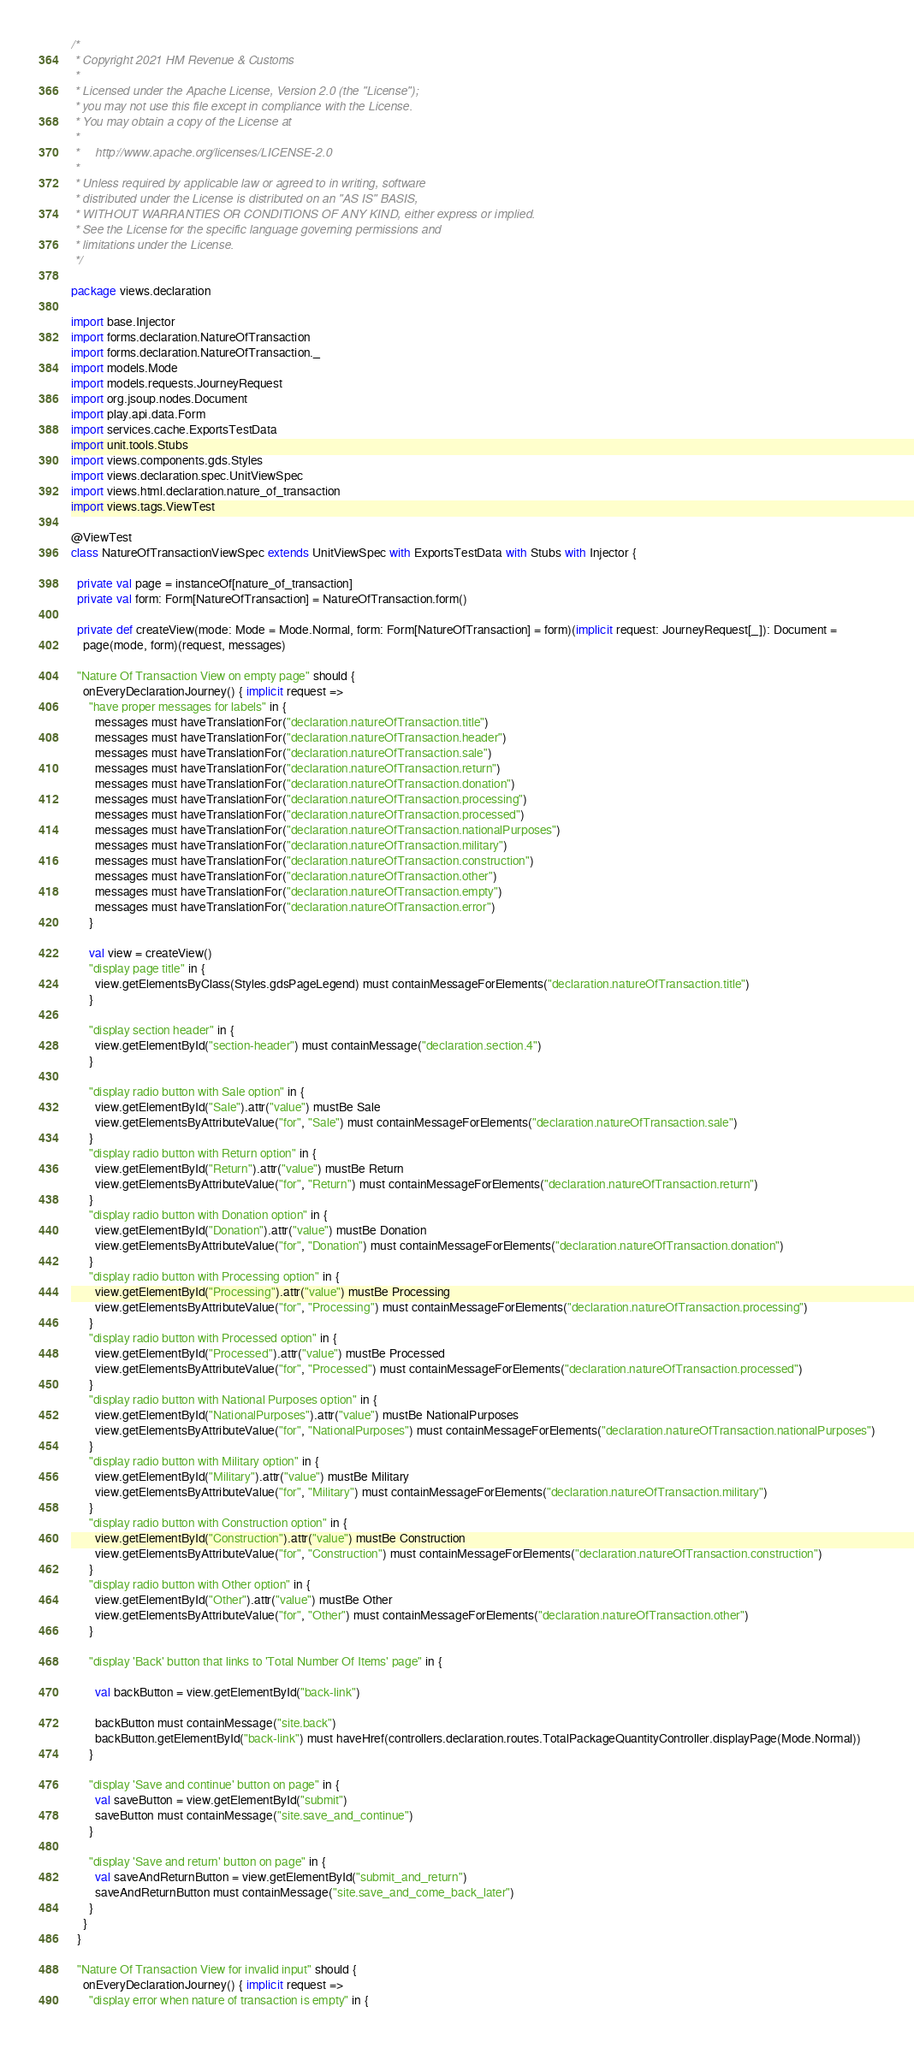Convert code to text. <code><loc_0><loc_0><loc_500><loc_500><_Scala_>/*
 * Copyright 2021 HM Revenue & Customs
 *
 * Licensed under the Apache License, Version 2.0 (the "License");
 * you may not use this file except in compliance with the License.
 * You may obtain a copy of the License at
 *
 *     http://www.apache.org/licenses/LICENSE-2.0
 *
 * Unless required by applicable law or agreed to in writing, software
 * distributed under the License is distributed on an "AS IS" BASIS,
 * WITHOUT WARRANTIES OR CONDITIONS OF ANY KIND, either express or implied.
 * See the License for the specific language governing permissions and
 * limitations under the License.
 */

package views.declaration

import base.Injector
import forms.declaration.NatureOfTransaction
import forms.declaration.NatureOfTransaction._
import models.Mode
import models.requests.JourneyRequest
import org.jsoup.nodes.Document
import play.api.data.Form
import services.cache.ExportsTestData
import unit.tools.Stubs
import views.components.gds.Styles
import views.declaration.spec.UnitViewSpec
import views.html.declaration.nature_of_transaction
import views.tags.ViewTest

@ViewTest
class NatureOfTransactionViewSpec extends UnitViewSpec with ExportsTestData with Stubs with Injector {

  private val page = instanceOf[nature_of_transaction]
  private val form: Form[NatureOfTransaction] = NatureOfTransaction.form()

  private def createView(mode: Mode = Mode.Normal, form: Form[NatureOfTransaction] = form)(implicit request: JourneyRequest[_]): Document =
    page(mode, form)(request, messages)

  "Nature Of Transaction View on empty page" should {
    onEveryDeclarationJourney() { implicit request =>
      "have proper messages for labels" in {
        messages must haveTranslationFor("declaration.natureOfTransaction.title")
        messages must haveTranslationFor("declaration.natureOfTransaction.header")
        messages must haveTranslationFor("declaration.natureOfTransaction.sale")
        messages must haveTranslationFor("declaration.natureOfTransaction.return")
        messages must haveTranslationFor("declaration.natureOfTransaction.donation")
        messages must haveTranslationFor("declaration.natureOfTransaction.processing")
        messages must haveTranslationFor("declaration.natureOfTransaction.processed")
        messages must haveTranslationFor("declaration.natureOfTransaction.nationalPurposes")
        messages must haveTranslationFor("declaration.natureOfTransaction.military")
        messages must haveTranslationFor("declaration.natureOfTransaction.construction")
        messages must haveTranslationFor("declaration.natureOfTransaction.other")
        messages must haveTranslationFor("declaration.natureOfTransaction.empty")
        messages must haveTranslationFor("declaration.natureOfTransaction.error")
      }

      val view = createView()
      "display page title" in {
        view.getElementsByClass(Styles.gdsPageLegend) must containMessageForElements("declaration.natureOfTransaction.title")
      }

      "display section header" in {
        view.getElementById("section-header") must containMessage("declaration.section.4")
      }

      "display radio button with Sale option" in {
        view.getElementById("Sale").attr("value") mustBe Sale
        view.getElementsByAttributeValue("for", "Sale") must containMessageForElements("declaration.natureOfTransaction.sale")
      }
      "display radio button with Return option" in {
        view.getElementById("Return").attr("value") mustBe Return
        view.getElementsByAttributeValue("for", "Return") must containMessageForElements("declaration.natureOfTransaction.return")
      }
      "display radio button with Donation option" in {
        view.getElementById("Donation").attr("value") mustBe Donation
        view.getElementsByAttributeValue("for", "Donation") must containMessageForElements("declaration.natureOfTransaction.donation")
      }
      "display radio button with Processing option" in {
        view.getElementById("Processing").attr("value") mustBe Processing
        view.getElementsByAttributeValue("for", "Processing") must containMessageForElements("declaration.natureOfTransaction.processing")
      }
      "display radio button with Processed option" in {
        view.getElementById("Processed").attr("value") mustBe Processed
        view.getElementsByAttributeValue("for", "Processed") must containMessageForElements("declaration.natureOfTransaction.processed")
      }
      "display radio button with National Purposes option" in {
        view.getElementById("NationalPurposes").attr("value") mustBe NationalPurposes
        view.getElementsByAttributeValue("for", "NationalPurposes") must containMessageForElements("declaration.natureOfTransaction.nationalPurposes")
      }
      "display radio button with Military option" in {
        view.getElementById("Military").attr("value") mustBe Military
        view.getElementsByAttributeValue("for", "Military") must containMessageForElements("declaration.natureOfTransaction.military")
      }
      "display radio button with Construction option" in {
        view.getElementById("Construction").attr("value") mustBe Construction
        view.getElementsByAttributeValue("for", "Construction") must containMessageForElements("declaration.natureOfTransaction.construction")
      }
      "display radio button with Other option" in {
        view.getElementById("Other").attr("value") mustBe Other
        view.getElementsByAttributeValue("for", "Other") must containMessageForElements("declaration.natureOfTransaction.other")
      }

      "display 'Back' button that links to 'Total Number Of Items' page" in {

        val backButton = view.getElementById("back-link")

        backButton must containMessage("site.back")
        backButton.getElementById("back-link") must haveHref(controllers.declaration.routes.TotalPackageQuantityController.displayPage(Mode.Normal))
      }

      "display 'Save and continue' button on page" in {
        val saveButton = view.getElementById("submit")
        saveButton must containMessage("site.save_and_continue")
      }

      "display 'Save and return' button on page" in {
        val saveAndReturnButton = view.getElementById("submit_and_return")
        saveAndReturnButton must containMessage("site.save_and_come_back_later")
      }
    }
  }

  "Nature Of Transaction View for invalid input" should {
    onEveryDeclarationJourney() { implicit request =>
      "display error when nature of transaction is empty" in {</code> 